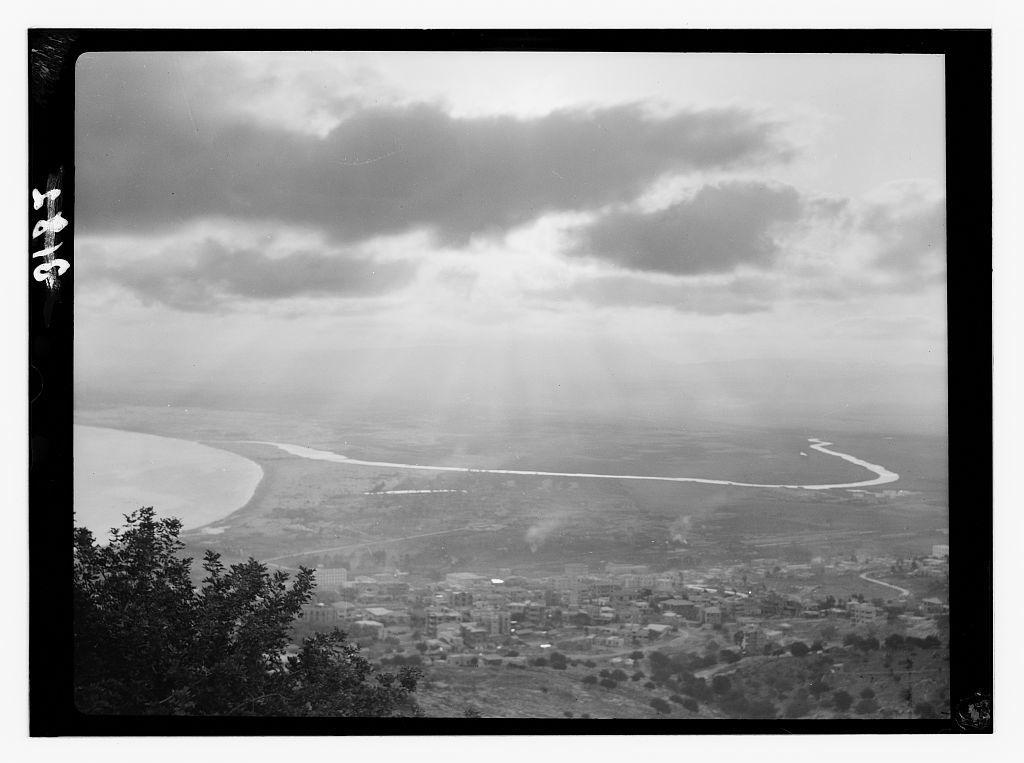What color scheme is used in the image? The image is monochrome. What type of tooth disease can be seen in the image? There is no tooth or any indication of a disease present in the image, as it is monochrome and does not depict any medical conditions. 